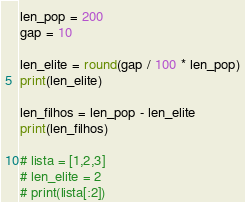<code> <loc_0><loc_0><loc_500><loc_500><_Python_>len_pop = 200
gap = 10

len_elite = round(gap / 100 * len_pop)
print(len_elite)

len_filhos = len_pop - len_elite
print(len_filhos)

# lista = [1,2,3]
# len_elite = 2
# print(lista[:2])

</code> 